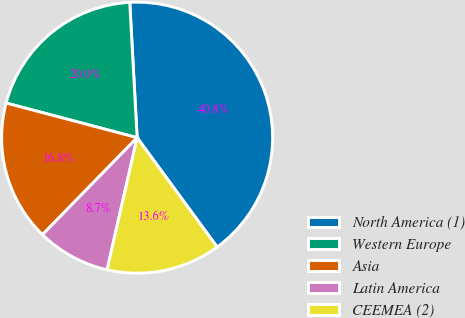<chart> <loc_0><loc_0><loc_500><loc_500><pie_chart><fcel>North America (1)<fcel>Western Europe<fcel>Asia<fcel>Latin America<fcel>CEEMEA (2)<nl><fcel>40.82%<fcel>20.02%<fcel>16.81%<fcel>8.75%<fcel>13.61%<nl></chart> 